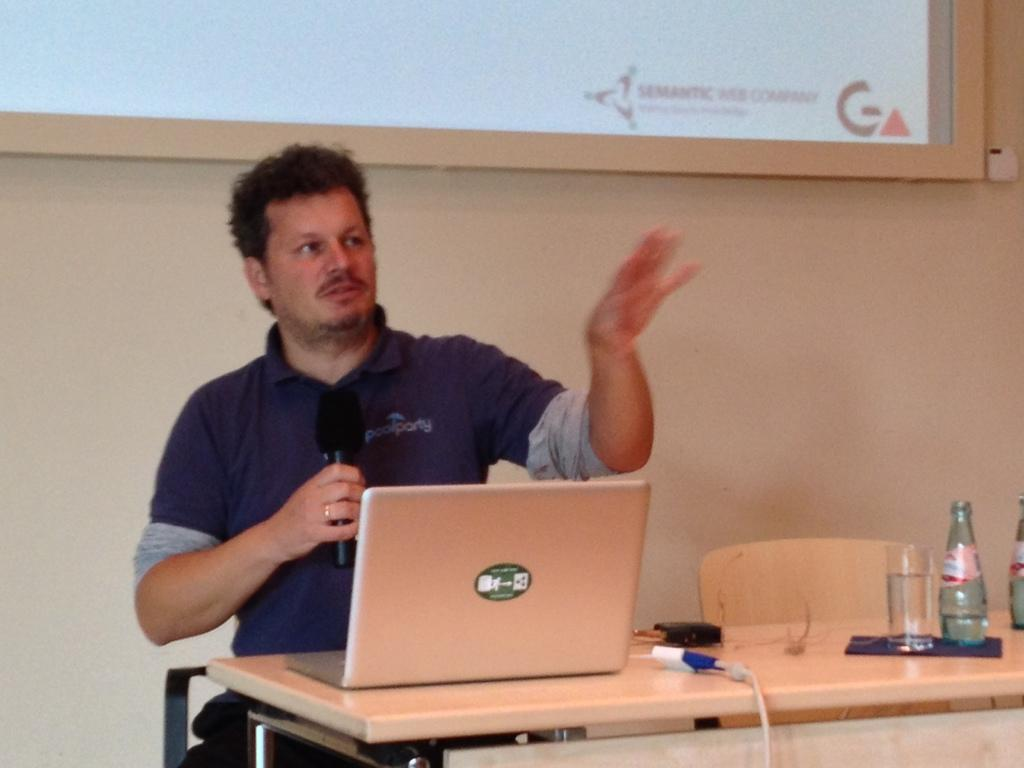<image>
Render a clear and concise summary of the photo. man with a poolparty logo shirt gesturing with microphone and gesturing with other arm while sitting behind a laptop 